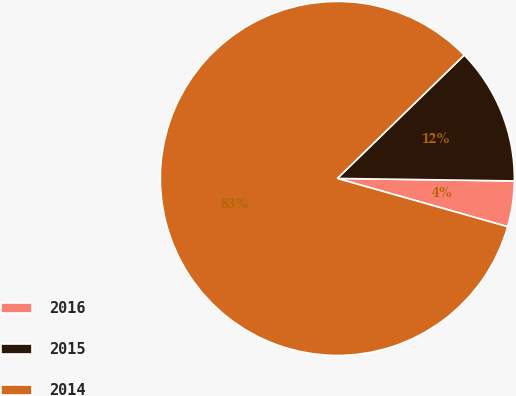Convert chart to OTSL. <chart><loc_0><loc_0><loc_500><loc_500><pie_chart><fcel>2016<fcel>2015<fcel>2014<nl><fcel>4.17%<fcel>12.5%<fcel>83.33%<nl></chart> 